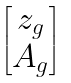Convert formula to latex. <formula><loc_0><loc_0><loc_500><loc_500>\begin{bmatrix} z _ { g } \\ A _ { g } \end{bmatrix}</formula> 